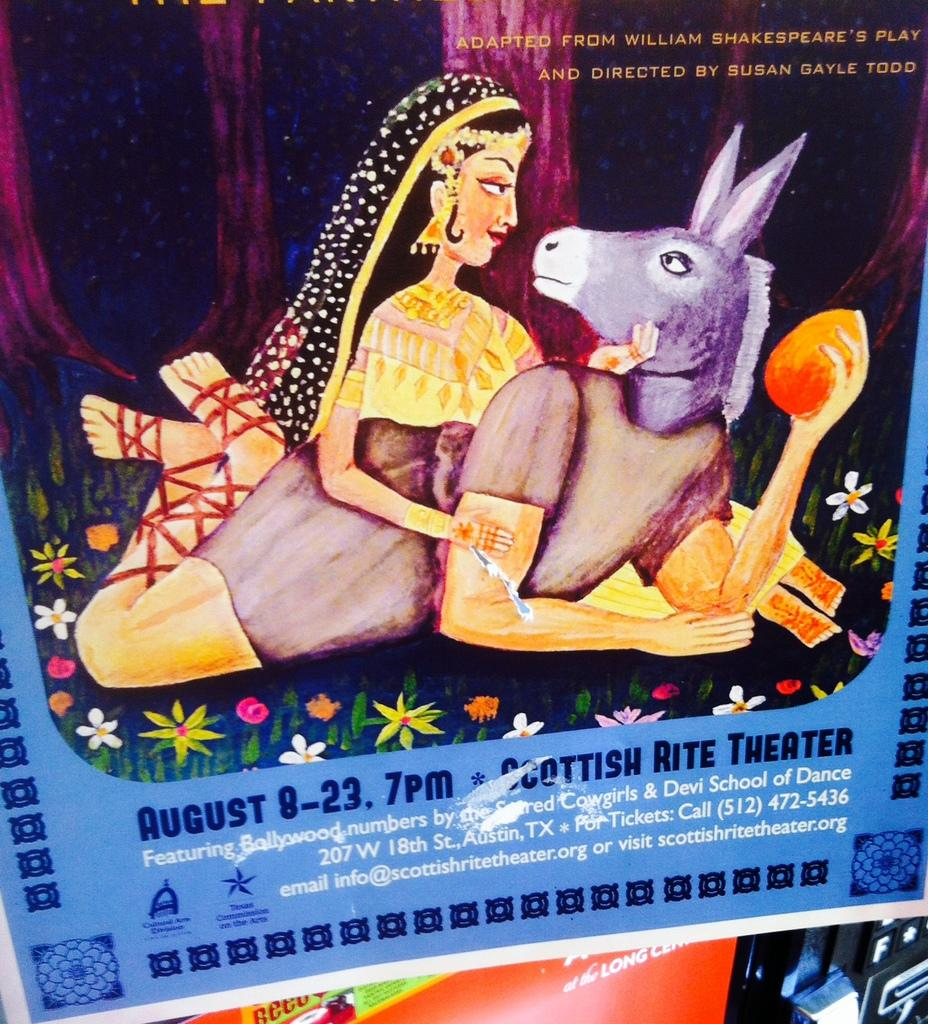What can be seen on the posts in the image? The posts have images and text in the image. Can you describe the object in the bottom right corner of the image? Unfortunately, the provided facts do not give enough information to describe the object in the bottom right corner of the image. What type of leather is being used in the science experiment depicted in the image? There is no leather or science experiment present in the image. Is the lawyer in the image wearing a suit? There is no lawyer present in the image. 